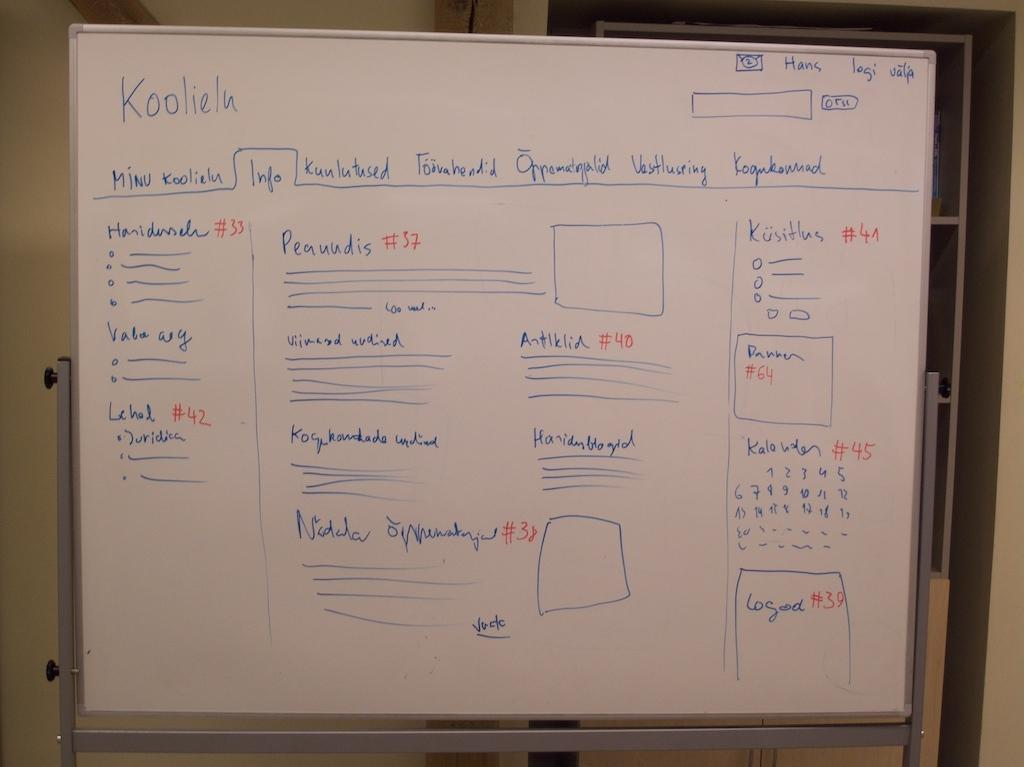<image>
Share a concise interpretation of the image provided. the number 37 that is on a white board 